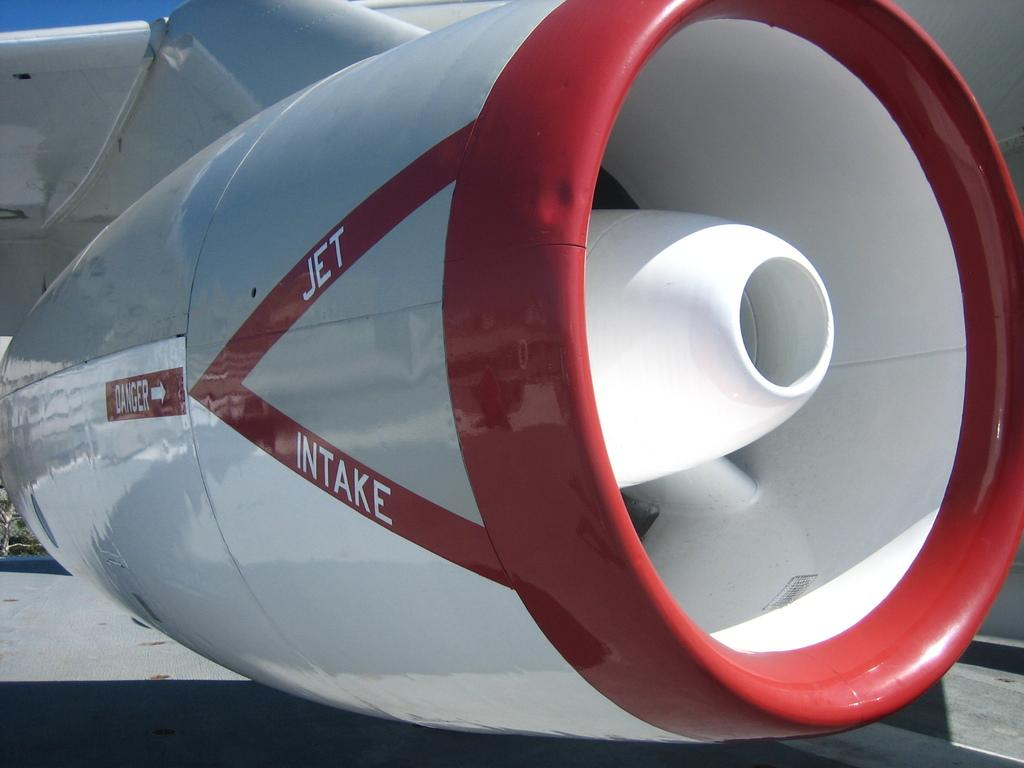<image>
Offer a succinct explanation of the picture presented. the word intake is on the engine of the plane 